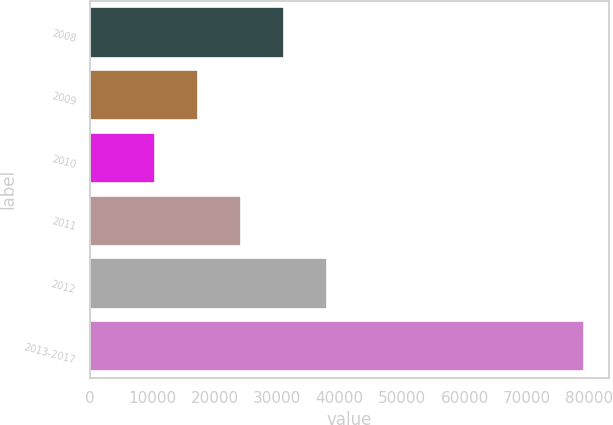<chart> <loc_0><loc_0><loc_500><loc_500><bar_chart><fcel>2008<fcel>2009<fcel>2010<fcel>2011<fcel>2012<fcel>2013-2017<nl><fcel>31066.8<fcel>17319.6<fcel>10446<fcel>24193.2<fcel>37940.4<fcel>79182<nl></chart> 